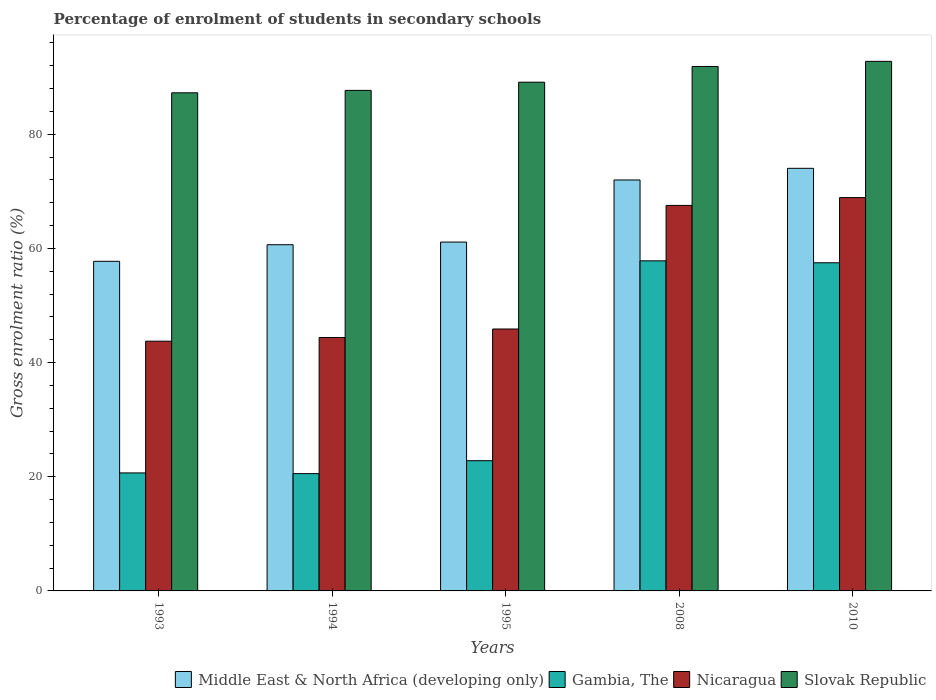How many bars are there on the 4th tick from the left?
Give a very brief answer. 4. What is the label of the 4th group of bars from the left?
Offer a terse response. 2008. In how many cases, is the number of bars for a given year not equal to the number of legend labels?
Your answer should be very brief. 0. What is the percentage of students enrolled in secondary schools in Slovak Republic in 2010?
Your answer should be compact. 92.78. Across all years, what is the maximum percentage of students enrolled in secondary schools in Nicaragua?
Your response must be concise. 68.91. Across all years, what is the minimum percentage of students enrolled in secondary schools in Gambia, The?
Ensure brevity in your answer.  20.55. In which year was the percentage of students enrolled in secondary schools in Nicaragua maximum?
Offer a very short reply. 2010. In which year was the percentage of students enrolled in secondary schools in Middle East & North Africa (developing only) minimum?
Make the answer very short. 1993. What is the total percentage of students enrolled in secondary schools in Nicaragua in the graph?
Your response must be concise. 270.48. What is the difference between the percentage of students enrolled in secondary schools in Gambia, The in 2008 and that in 2010?
Ensure brevity in your answer.  0.34. What is the difference between the percentage of students enrolled in secondary schools in Gambia, The in 2010 and the percentage of students enrolled in secondary schools in Nicaragua in 1994?
Keep it short and to the point. 13.09. What is the average percentage of students enrolled in secondary schools in Slovak Republic per year?
Offer a very short reply. 89.75. In the year 1993, what is the difference between the percentage of students enrolled in secondary schools in Gambia, The and percentage of students enrolled in secondary schools in Nicaragua?
Keep it short and to the point. -23.08. In how many years, is the percentage of students enrolled in secondary schools in Slovak Republic greater than 64 %?
Provide a succinct answer. 5. What is the ratio of the percentage of students enrolled in secondary schools in Gambia, The in 1995 to that in 2010?
Your answer should be very brief. 0.4. Is the difference between the percentage of students enrolled in secondary schools in Gambia, The in 1993 and 2010 greater than the difference between the percentage of students enrolled in secondary schools in Nicaragua in 1993 and 2010?
Keep it short and to the point. No. What is the difference between the highest and the second highest percentage of students enrolled in secondary schools in Slovak Republic?
Provide a succinct answer. 0.9. What is the difference between the highest and the lowest percentage of students enrolled in secondary schools in Gambia, The?
Make the answer very short. 37.28. In how many years, is the percentage of students enrolled in secondary schools in Slovak Republic greater than the average percentage of students enrolled in secondary schools in Slovak Republic taken over all years?
Ensure brevity in your answer.  2. What does the 3rd bar from the left in 2010 represents?
Offer a terse response. Nicaragua. What does the 1st bar from the right in 1995 represents?
Provide a short and direct response. Slovak Republic. How many bars are there?
Give a very brief answer. 20. Are all the bars in the graph horizontal?
Give a very brief answer. No. How many years are there in the graph?
Provide a succinct answer. 5. Does the graph contain grids?
Give a very brief answer. No. Where does the legend appear in the graph?
Your answer should be very brief. Bottom right. How many legend labels are there?
Give a very brief answer. 4. How are the legend labels stacked?
Provide a succinct answer. Horizontal. What is the title of the graph?
Give a very brief answer. Percentage of enrolment of students in secondary schools. Does "Vanuatu" appear as one of the legend labels in the graph?
Offer a terse response. No. What is the label or title of the X-axis?
Your answer should be compact. Years. What is the label or title of the Y-axis?
Keep it short and to the point. Gross enrolment ratio (%). What is the Gross enrolment ratio (%) in Middle East & North Africa (developing only) in 1993?
Your answer should be very brief. 57.75. What is the Gross enrolment ratio (%) in Gambia, The in 1993?
Your answer should be very brief. 20.67. What is the Gross enrolment ratio (%) of Nicaragua in 1993?
Your answer should be compact. 43.75. What is the Gross enrolment ratio (%) of Slovak Republic in 1993?
Your answer should be very brief. 87.27. What is the Gross enrolment ratio (%) of Middle East & North Africa (developing only) in 1994?
Keep it short and to the point. 60.65. What is the Gross enrolment ratio (%) of Gambia, The in 1994?
Your answer should be very brief. 20.55. What is the Gross enrolment ratio (%) of Nicaragua in 1994?
Make the answer very short. 44.4. What is the Gross enrolment ratio (%) of Slovak Republic in 1994?
Offer a terse response. 87.69. What is the Gross enrolment ratio (%) of Middle East & North Africa (developing only) in 1995?
Your answer should be compact. 61.11. What is the Gross enrolment ratio (%) of Gambia, The in 1995?
Your answer should be very brief. 22.81. What is the Gross enrolment ratio (%) of Nicaragua in 1995?
Keep it short and to the point. 45.89. What is the Gross enrolment ratio (%) of Slovak Republic in 1995?
Your response must be concise. 89.13. What is the Gross enrolment ratio (%) in Middle East & North Africa (developing only) in 2008?
Your answer should be compact. 71.99. What is the Gross enrolment ratio (%) in Gambia, The in 2008?
Your answer should be compact. 57.83. What is the Gross enrolment ratio (%) of Nicaragua in 2008?
Your response must be concise. 67.54. What is the Gross enrolment ratio (%) in Slovak Republic in 2008?
Your response must be concise. 91.88. What is the Gross enrolment ratio (%) in Middle East & North Africa (developing only) in 2010?
Provide a succinct answer. 74.04. What is the Gross enrolment ratio (%) in Gambia, The in 2010?
Offer a very short reply. 57.49. What is the Gross enrolment ratio (%) in Nicaragua in 2010?
Make the answer very short. 68.91. What is the Gross enrolment ratio (%) in Slovak Republic in 2010?
Provide a succinct answer. 92.78. Across all years, what is the maximum Gross enrolment ratio (%) of Middle East & North Africa (developing only)?
Provide a succinct answer. 74.04. Across all years, what is the maximum Gross enrolment ratio (%) of Gambia, The?
Your response must be concise. 57.83. Across all years, what is the maximum Gross enrolment ratio (%) of Nicaragua?
Provide a succinct answer. 68.91. Across all years, what is the maximum Gross enrolment ratio (%) in Slovak Republic?
Your answer should be very brief. 92.78. Across all years, what is the minimum Gross enrolment ratio (%) of Middle East & North Africa (developing only)?
Offer a very short reply. 57.75. Across all years, what is the minimum Gross enrolment ratio (%) in Gambia, The?
Ensure brevity in your answer.  20.55. Across all years, what is the minimum Gross enrolment ratio (%) in Nicaragua?
Offer a terse response. 43.75. Across all years, what is the minimum Gross enrolment ratio (%) of Slovak Republic?
Provide a short and direct response. 87.27. What is the total Gross enrolment ratio (%) in Middle East & North Africa (developing only) in the graph?
Keep it short and to the point. 325.54. What is the total Gross enrolment ratio (%) of Gambia, The in the graph?
Offer a terse response. 179.35. What is the total Gross enrolment ratio (%) in Nicaragua in the graph?
Provide a succinct answer. 270.48. What is the total Gross enrolment ratio (%) of Slovak Republic in the graph?
Offer a terse response. 448.73. What is the difference between the Gross enrolment ratio (%) in Middle East & North Africa (developing only) in 1993 and that in 1994?
Offer a very short reply. -2.91. What is the difference between the Gross enrolment ratio (%) of Gambia, The in 1993 and that in 1994?
Keep it short and to the point. 0.12. What is the difference between the Gross enrolment ratio (%) of Nicaragua in 1993 and that in 1994?
Your answer should be very brief. -0.65. What is the difference between the Gross enrolment ratio (%) of Slovak Republic in 1993 and that in 1994?
Offer a terse response. -0.42. What is the difference between the Gross enrolment ratio (%) of Middle East & North Africa (developing only) in 1993 and that in 1995?
Offer a terse response. -3.37. What is the difference between the Gross enrolment ratio (%) of Gambia, The in 1993 and that in 1995?
Your answer should be very brief. -2.14. What is the difference between the Gross enrolment ratio (%) in Nicaragua in 1993 and that in 1995?
Your answer should be very brief. -2.13. What is the difference between the Gross enrolment ratio (%) of Slovak Republic in 1993 and that in 1995?
Keep it short and to the point. -1.86. What is the difference between the Gross enrolment ratio (%) in Middle East & North Africa (developing only) in 1993 and that in 2008?
Make the answer very short. -14.25. What is the difference between the Gross enrolment ratio (%) in Gambia, The in 1993 and that in 2008?
Your answer should be compact. -37.15. What is the difference between the Gross enrolment ratio (%) in Nicaragua in 1993 and that in 2008?
Your answer should be very brief. -23.79. What is the difference between the Gross enrolment ratio (%) in Slovak Republic in 1993 and that in 2008?
Make the answer very short. -4.61. What is the difference between the Gross enrolment ratio (%) in Middle East & North Africa (developing only) in 1993 and that in 2010?
Make the answer very short. -16.29. What is the difference between the Gross enrolment ratio (%) in Gambia, The in 1993 and that in 2010?
Offer a terse response. -36.81. What is the difference between the Gross enrolment ratio (%) of Nicaragua in 1993 and that in 2010?
Provide a succinct answer. -25.16. What is the difference between the Gross enrolment ratio (%) of Slovak Republic in 1993 and that in 2010?
Provide a succinct answer. -5.51. What is the difference between the Gross enrolment ratio (%) in Middle East & North Africa (developing only) in 1994 and that in 1995?
Provide a succinct answer. -0.46. What is the difference between the Gross enrolment ratio (%) of Gambia, The in 1994 and that in 1995?
Make the answer very short. -2.27. What is the difference between the Gross enrolment ratio (%) of Nicaragua in 1994 and that in 1995?
Make the answer very short. -1.49. What is the difference between the Gross enrolment ratio (%) in Slovak Republic in 1994 and that in 1995?
Offer a terse response. -1.44. What is the difference between the Gross enrolment ratio (%) of Middle East & North Africa (developing only) in 1994 and that in 2008?
Provide a short and direct response. -11.34. What is the difference between the Gross enrolment ratio (%) in Gambia, The in 1994 and that in 2008?
Make the answer very short. -37.28. What is the difference between the Gross enrolment ratio (%) in Nicaragua in 1994 and that in 2008?
Make the answer very short. -23.14. What is the difference between the Gross enrolment ratio (%) in Slovak Republic in 1994 and that in 2008?
Provide a short and direct response. -4.19. What is the difference between the Gross enrolment ratio (%) in Middle East & North Africa (developing only) in 1994 and that in 2010?
Your response must be concise. -13.39. What is the difference between the Gross enrolment ratio (%) of Gambia, The in 1994 and that in 2010?
Provide a short and direct response. -36.94. What is the difference between the Gross enrolment ratio (%) of Nicaragua in 1994 and that in 2010?
Keep it short and to the point. -24.51. What is the difference between the Gross enrolment ratio (%) of Slovak Republic in 1994 and that in 2010?
Give a very brief answer. -5.09. What is the difference between the Gross enrolment ratio (%) of Middle East & North Africa (developing only) in 1995 and that in 2008?
Give a very brief answer. -10.88. What is the difference between the Gross enrolment ratio (%) in Gambia, The in 1995 and that in 2008?
Your response must be concise. -35.01. What is the difference between the Gross enrolment ratio (%) of Nicaragua in 1995 and that in 2008?
Provide a succinct answer. -21.65. What is the difference between the Gross enrolment ratio (%) in Slovak Republic in 1995 and that in 2008?
Offer a very short reply. -2.75. What is the difference between the Gross enrolment ratio (%) in Middle East & North Africa (developing only) in 1995 and that in 2010?
Provide a short and direct response. -12.92. What is the difference between the Gross enrolment ratio (%) in Gambia, The in 1995 and that in 2010?
Give a very brief answer. -34.67. What is the difference between the Gross enrolment ratio (%) in Nicaragua in 1995 and that in 2010?
Provide a succinct answer. -23.02. What is the difference between the Gross enrolment ratio (%) of Slovak Republic in 1995 and that in 2010?
Your answer should be very brief. -3.65. What is the difference between the Gross enrolment ratio (%) of Middle East & North Africa (developing only) in 2008 and that in 2010?
Ensure brevity in your answer.  -2.04. What is the difference between the Gross enrolment ratio (%) of Gambia, The in 2008 and that in 2010?
Keep it short and to the point. 0.34. What is the difference between the Gross enrolment ratio (%) in Nicaragua in 2008 and that in 2010?
Your response must be concise. -1.37. What is the difference between the Gross enrolment ratio (%) of Slovak Republic in 2008 and that in 2010?
Keep it short and to the point. -0.9. What is the difference between the Gross enrolment ratio (%) in Middle East & North Africa (developing only) in 1993 and the Gross enrolment ratio (%) in Gambia, The in 1994?
Your answer should be very brief. 37.2. What is the difference between the Gross enrolment ratio (%) in Middle East & North Africa (developing only) in 1993 and the Gross enrolment ratio (%) in Nicaragua in 1994?
Offer a terse response. 13.35. What is the difference between the Gross enrolment ratio (%) in Middle East & North Africa (developing only) in 1993 and the Gross enrolment ratio (%) in Slovak Republic in 1994?
Give a very brief answer. -29.94. What is the difference between the Gross enrolment ratio (%) of Gambia, The in 1993 and the Gross enrolment ratio (%) of Nicaragua in 1994?
Ensure brevity in your answer.  -23.72. What is the difference between the Gross enrolment ratio (%) in Gambia, The in 1993 and the Gross enrolment ratio (%) in Slovak Republic in 1994?
Your answer should be very brief. -67.02. What is the difference between the Gross enrolment ratio (%) of Nicaragua in 1993 and the Gross enrolment ratio (%) of Slovak Republic in 1994?
Provide a short and direct response. -43.94. What is the difference between the Gross enrolment ratio (%) in Middle East & North Africa (developing only) in 1993 and the Gross enrolment ratio (%) in Gambia, The in 1995?
Provide a succinct answer. 34.93. What is the difference between the Gross enrolment ratio (%) of Middle East & North Africa (developing only) in 1993 and the Gross enrolment ratio (%) of Nicaragua in 1995?
Provide a succinct answer. 11.86. What is the difference between the Gross enrolment ratio (%) in Middle East & North Africa (developing only) in 1993 and the Gross enrolment ratio (%) in Slovak Republic in 1995?
Give a very brief answer. -31.38. What is the difference between the Gross enrolment ratio (%) of Gambia, The in 1993 and the Gross enrolment ratio (%) of Nicaragua in 1995?
Offer a very short reply. -25.21. What is the difference between the Gross enrolment ratio (%) of Gambia, The in 1993 and the Gross enrolment ratio (%) of Slovak Republic in 1995?
Ensure brevity in your answer.  -68.45. What is the difference between the Gross enrolment ratio (%) of Nicaragua in 1993 and the Gross enrolment ratio (%) of Slovak Republic in 1995?
Offer a terse response. -45.37. What is the difference between the Gross enrolment ratio (%) in Middle East & North Africa (developing only) in 1993 and the Gross enrolment ratio (%) in Gambia, The in 2008?
Ensure brevity in your answer.  -0.08. What is the difference between the Gross enrolment ratio (%) of Middle East & North Africa (developing only) in 1993 and the Gross enrolment ratio (%) of Nicaragua in 2008?
Offer a very short reply. -9.79. What is the difference between the Gross enrolment ratio (%) of Middle East & North Africa (developing only) in 1993 and the Gross enrolment ratio (%) of Slovak Republic in 2008?
Make the answer very short. -34.13. What is the difference between the Gross enrolment ratio (%) in Gambia, The in 1993 and the Gross enrolment ratio (%) in Nicaragua in 2008?
Offer a terse response. -46.86. What is the difference between the Gross enrolment ratio (%) in Gambia, The in 1993 and the Gross enrolment ratio (%) in Slovak Republic in 2008?
Make the answer very short. -71.2. What is the difference between the Gross enrolment ratio (%) of Nicaragua in 1993 and the Gross enrolment ratio (%) of Slovak Republic in 2008?
Your response must be concise. -48.13. What is the difference between the Gross enrolment ratio (%) of Middle East & North Africa (developing only) in 1993 and the Gross enrolment ratio (%) of Gambia, The in 2010?
Provide a short and direct response. 0.26. What is the difference between the Gross enrolment ratio (%) in Middle East & North Africa (developing only) in 1993 and the Gross enrolment ratio (%) in Nicaragua in 2010?
Your answer should be very brief. -11.16. What is the difference between the Gross enrolment ratio (%) of Middle East & North Africa (developing only) in 1993 and the Gross enrolment ratio (%) of Slovak Republic in 2010?
Give a very brief answer. -35.03. What is the difference between the Gross enrolment ratio (%) of Gambia, The in 1993 and the Gross enrolment ratio (%) of Nicaragua in 2010?
Keep it short and to the point. -48.23. What is the difference between the Gross enrolment ratio (%) in Gambia, The in 1993 and the Gross enrolment ratio (%) in Slovak Republic in 2010?
Provide a succinct answer. -72.1. What is the difference between the Gross enrolment ratio (%) in Nicaragua in 1993 and the Gross enrolment ratio (%) in Slovak Republic in 2010?
Your response must be concise. -49.02. What is the difference between the Gross enrolment ratio (%) in Middle East & North Africa (developing only) in 1994 and the Gross enrolment ratio (%) in Gambia, The in 1995?
Your answer should be very brief. 37.84. What is the difference between the Gross enrolment ratio (%) in Middle East & North Africa (developing only) in 1994 and the Gross enrolment ratio (%) in Nicaragua in 1995?
Ensure brevity in your answer.  14.77. What is the difference between the Gross enrolment ratio (%) of Middle East & North Africa (developing only) in 1994 and the Gross enrolment ratio (%) of Slovak Republic in 1995?
Ensure brevity in your answer.  -28.47. What is the difference between the Gross enrolment ratio (%) in Gambia, The in 1994 and the Gross enrolment ratio (%) in Nicaragua in 1995?
Give a very brief answer. -25.34. What is the difference between the Gross enrolment ratio (%) of Gambia, The in 1994 and the Gross enrolment ratio (%) of Slovak Republic in 1995?
Give a very brief answer. -68.58. What is the difference between the Gross enrolment ratio (%) in Nicaragua in 1994 and the Gross enrolment ratio (%) in Slovak Republic in 1995?
Provide a succinct answer. -44.73. What is the difference between the Gross enrolment ratio (%) in Middle East & North Africa (developing only) in 1994 and the Gross enrolment ratio (%) in Gambia, The in 2008?
Keep it short and to the point. 2.82. What is the difference between the Gross enrolment ratio (%) in Middle East & North Africa (developing only) in 1994 and the Gross enrolment ratio (%) in Nicaragua in 2008?
Your answer should be compact. -6.89. What is the difference between the Gross enrolment ratio (%) of Middle East & North Africa (developing only) in 1994 and the Gross enrolment ratio (%) of Slovak Republic in 2008?
Offer a very short reply. -31.23. What is the difference between the Gross enrolment ratio (%) of Gambia, The in 1994 and the Gross enrolment ratio (%) of Nicaragua in 2008?
Provide a short and direct response. -46.99. What is the difference between the Gross enrolment ratio (%) of Gambia, The in 1994 and the Gross enrolment ratio (%) of Slovak Republic in 2008?
Your answer should be very brief. -71.33. What is the difference between the Gross enrolment ratio (%) in Nicaragua in 1994 and the Gross enrolment ratio (%) in Slovak Republic in 2008?
Offer a terse response. -47.48. What is the difference between the Gross enrolment ratio (%) of Middle East & North Africa (developing only) in 1994 and the Gross enrolment ratio (%) of Gambia, The in 2010?
Give a very brief answer. 3.16. What is the difference between the Gross enrolment ratio (%) in Middle East & North Africa (developing only) in 1994 and the Gross enrolment ratio (%) in Nicaragua in 2010?
Keep it short and to the point. -8.26. What is the difference between the Gross enrolment ratio (%) in Middle East & North Africa (developing only) in 1994 and the Gross enrolment ratio (%) in Slovak Republic in 2010?
Ensure brevity in your answer.  -32.12. What is the difference between the Gross enrolment ratio (%) of Gambia, The in 1994 and the Gross enrolment ratio (%) of Nicaragua in 2010?
Offer a terse response. -48.36. What is the difference between the Gross enrolment ratio (%) in Gambia, The in 1994 and the Gross enrolment ratio (%) in Slovak Republic in 2010?
Your answer should be very brief. -72.23. What is the difference between the Gross enrolment ratio (%) of Nicaragua in 1994 and the Gross enrolment ratio (%) of Slovak Republic in 2010?
Your response must be concise. -48.38. What is the difference between the Gross enrolment ratio (%) in Middle East & North Africa (developing only) in 1995 and the Gross enrolment ratio (%) in Gambia, The in 2008?
Your answer should be compact. 3.29. What is the difference between the Gross enrolment ratio (%) in Middle East & North Africa (developing only) in 1995 and the Gross enrolment ratio (%) in Nicaragua in 2008?
Make the answer very short. -6.42. What is the difference between the Gross enrolment ratio (%) of Middle East & North Africa (developing only) in 1995 and the Gross enrolment ratio (%) of Slovak Republic in 2008?
Make the answer very short. -30.76. What is the difference between the Gross enrolment ratio (%) in Gambia, The in 1995 and the Gross enrolment ratio (%) in Nicaragua in 2008?
Make the answer very short. -44.72. What is the difference between the Gross enrolment ratio (%) of Gambia, The in 1995 and the Gross enrolment ratio (%) of Slovak Republic in 2008?
Provide a succinct answer. -69.06. What is the difference between the Gross enrolment ratio (%) in Nicaragua in 1995 and the Gross enrolment ratio (%) in Slovak Republic in 2008?
Your response must be concise. -45.99. What is the difference between the Gross enrolment ratio (%) of Middle East & North Africa (developing only) in 1995 and the Gross enrolment ratio (%) of Gambia, The in 2010?
Offer a very short reply. 3.63. What is the difference between the Gross enrolment ratio (%) in Middle East & North Africa (developing only) in 1995 and the Gross enrolment ratio (%) in Nicaragua in 2010?
Ensure brevity in your answer.  -7.79. What is the difference between the Gross enrolment ratio (%) in Middle East & North Africa (developing only) in 1995 and the Gross enrolment ratio (%) in Slovak Republic in 2010?
Your answer should be very brief. -31.66. What is the difference between the Gross enrolment ratio (%) of Gambia, The in 1995 and the Gross enrolment ratio (%) of Nicaragua in 2010?
Your answer should be very brief. -46.09. What is the difference between the Gross enrolment ratio (%) in Gambia, The in 1995 and the Gross enrolment ratio (%) in Slovak Republic in 2010?
Keep it short and to the point. -69.96. What is the difference between the Gross enrolment ratio (%) of Nicaragua in 1995 and the Gross enrolment ratio (%) of Slovak Republic in 2010?
Ensure brevity in your answer.  -46.89. What is the difference between the Gross enrolment ratio (%) of Middle East & North Africa (developing only) in 2008 and the Gross enrolment ratio (%) of Gambia, The in 2010?
Your answer should be very brief. 14.51. What is the difference between the Gross enrolment ratio (%) in Middle East & North Africa (developing only) in 2008 and the Gross enrolment ratio (%) in Nicaragua in 2010?
Give a very brief answer. 3.08. What is the difference between the Gross enrolment ratio (%) in Middle East & North Africa (developing only) in 2008 and the Gross enrolment ratio (%) in Slovak Republic in 2010?
Offer a terse response. -20.78. What is the difference between the Gross enrolment ratio (%) of Gambia, The in 2008 and the Gross enrolment ratio (%) of Nicaragua in 2010?
Your response must be concise. -11.08. What is the difference between the Gross enrolment ratio (%) of Gambia, The in 2008 and the Gross enrolment ratio (%) of Slovak Republic in 2010?
Offer a very short reply. -34.95. What is the difference between the Gross enrolment ratio (%) in Nicaragua in 2008 and the Gross enrolment ratio (%) in Slovak Republic in 2010?
Provide a succinct answer. -25.24. What is the average Gross enrolment ratio (%) of Middle East & North Africa (developing only) per year?
Offer a very short reply. 65.11. What is the average Gross enrolment ratio (%) in Gambia, The per year?
Your answer should be compact. 35.87. What is the average Gross enrolment ratio (%) of Nicaragua per year?
Make the answer very short. 54.1. What is the average Gross enrolment ratio (%) of Slovak Republic per year?
Ensure brevity in your answer.  89.75. In the year 1993, what is the difference between the Gross enrolment ratio (%) in Middle East & North Africa (developing only) and Gross enrolment ratio (%) in Gambia, The?
Offer a terse response. 37.07. In the year 1993, what is the difference between the Gross enrolment ratio (%) of Middle East & North Africa (developing only) and Gross enrolment ratio (%) of Nicaragua?
Keep it short and to the point. 13.99. In the year 1993, what is the difference between the Gross enrolment ratio (%) in Middle East & North Africa (developing only) and Gross enrolment ratio (%) in Slovak Republic?
Keep it short and to the point. -29.52. In the year 1993, what is the difference between the Gross enrolment ratio (%) of Gambia, The and Gross enrolment ratio (%) of Nicaragua?
Provide a short and direct response. -23.08. In the year 1993, what is the difference between the Gross enrolment ratio (%) in Gambia, The and Gross enrolment ratio (%) in Slovak Republic?
Offer a terse response. -66.59. In the year 1993, what is the difference between the Gross enrolment ratio (%) in Nicaragua and Gross enrolment ratio (%) in Slovak Republic?
Offer a very short reply. -43.52. In the year 1994, what is the difference between the Gross enrolment ratio (%) in Middle East & North Africa (developing only) and Gross enrolment ratio (%) in Gambia, The?
Your answer should be compact. 40.1. In the year 1994, what is the difference between the Gross enrolment ratio (%) of Middle East & North Africa (developing only) and Gross enrolment ratio (%) of Nicaragua?
Give a very brief answer. 16.25. In the year 1994, what is the difference between the Gross enrolment ratio (%) of Middle East & North Africa (developing only) and Gross enrolment ratio (%) of Slovak Republic?
Your answer should be very brief. -27.04. In the year 1994, what is the difference between the Gross enrolment ratio (%) in Gambia, The and Gross enrolment ratio (%) in Nicaragua?
Offer a very short reply. -23.85. In the year 1994, what is the difference between the Gross enrolment ratio (%) of Gambia, The and Gross enrolment ratio (%) of Slovak Republic?
Offer a very short reply. -67.14. In the year 1994, what is the difference between the Gross enrolment ratio (%) of Nicaragua and Gross enrolment ratio (%) of Slovak Republic?
Make the answer very short. -43.29. In the year 1995, what is the difference between the Gross enrolment ratio (%) in Middle East & North Africa (developing only) and Gross enrolment ratio (%) in Gambia, The?
Make the answer very short. 38.3. In the year 1995, what is the difference between the Gross enrolment ratio (%) of Middle East & North Africa (developing only) and Gross enrolment ratio (%) of Nicaragua?
Provide a short and direct response. 15.23. In the year 1995, what is the difference between the Gross enrolment ratio (%) of Middle East & North Africa (developing only) and Gross enrolment ratio (%) of Slovak Republic?
Your answer should be compact. -28.01. In the year 1995, what is the difference between the Gross enrolment ratio (%) in Gambia, The and Gross enrolment ratio (%) in Nicaragua?
Make the answer very short. -23.07. In the year 1995, what is the difference between the Gross enrolment ratio (%) of Gambia, The and Gross enrolment ratio (%) of Slovak Republic?
Keep it short and to the point. -66.31. In the year 1995, what is the difference between the Gross enrolment ratio (%) in Nicaragua and Gross enrolment ratio (%) in Slovak Republic?
Give a very brief answer. -43.24. In the year 2008, what is the difference between the Gross enrolment ratio (%) in Middle East & North Africa (developing only) and Gross enrolment ratio (%) in Gambia, The?
Provide a succinct answer. 14.17. In the year 2008, what is the difference between the Gross enrolment ratio (%) in Middle East & North Africa (developing only) and Gross enrolment ratio (%) in Nicaragua?
Ensure brevity in your answer.  4.46. In the year 2008, what is the difference between the Gross enrolment ratio (%) of Middle East & North Africa (developing only) and Gross enrolment ratio (%) of Slovak Republic?
Ensure brevity in your answer.  -19.88. In the year 2008, what is the difference between the Gross enrolment ratio (%) in Gambia, The and Gross enrolment ratio (%) in Nicaragua?
Provide a succinct answer. -9.71. In the year 2008, what is the difference between the Gross enrolment ratio (%) in Gambia, The and Gross enrolment ratio (%) in Slovak Republic?
Give a very brief answer. -34.05. In the year 2008, what is the difference between the Gross enrolment ratio (%) in Nicaragua and Gross enrolment ratio (%) in Slovak Republic?
Your answer should be compact. -24.34. In the year 2010, what is the difference between the Gross enrolment ratio (%) of Middle East & North Africa (developing only) and Gross enrolment ratio (%) of Gambia, The?
Your response must be concise. 16.55. In the year 2010, what is the difference between the Gross enrolment ratio (%) of Middle East & North Africa (developing only) and Gross enrolment ratio (%) of Nicaragua?
Offer a terse response. 5.13. In the year 2010, what is the difference between the Gross enrolment ratio (%) in Middle East & North Africa (developing only) and Gross enrolment ratio (%) in Slovak Republic?
Your answer should be very brief. -18.74. In the year 2010, what is the difference between the Gross enrolment ratio (%) in Gambia, The and Gross enrolment ratio (%) in Nicaragua?
Provide a short and direct response. -11.42. In the year 2010, what is the difference between the Gross enrolment ratio (%) in Gambia, The and Gross enrolment ratio (%) in Slovak Republic?
Give a very brief answer. -35.29. In the year 2010, what is the difference between the Gross enrolment ratio (%) of Nicaragua and Gross enrolment ratio (%) of Slovak Republic?
Offer a terse response. -23.87. What is the ratio of the Gross enrolment ratio (%) in Middle East & North Africa (developing only) in 1993 to that in 1994?
Offer a very short reply. 0.95. What is the ratio of the Gross enrolment ratio (%) of Nicaragua in 1993 to that in 1994?
Offer a very short reply. 0.99. What is the ratio of the Gross enrolment ratio (%) of Slovak Republic in 1993 to that in 1994?
Provide a succinct answer. 1. What is the ratio of the Gross enrolment ratio (%) in Middle East & North Africa (developing only) in 1993 to that in 1995?
Provide a succinct answer. 0.94. What is the ratio of the Gross enrolment ratio (%) of Gambia, The in 1993 to that in 1995?
Make the answer very short. 0.91. What is the ratio of the Gross enrolment ratio (%) of Nicaragua in 1993 to that in 1995?
Your response must be concise. 0.95. What is the ratio of the Gross enrolment ratio (%) in Slovak Republic in 1993 to that in 1995?
Make the answer very short. 0.98. What is the ratio of the Gross enrolment ratio (%) in Middle East & North Africa (developing only) in 1993 to that in 2008?
Your answer should be very brief. 0.8. What is the ratio of the Gross enrolment ratio (%) in Gambia, The in 1993 to that in 2008?
Your response must be concise. 0.36. What is the ratio of the Gross enrolment ratio (%) in Nicaragua in 1993 to that in 2008?
Provide a short and direct response. 0.65. What is the ratio of the Gross enrolment ratio (%) in Slovak Republic in 1993 to that in 2008?
Offer a very short reply. 0.95. What is the ratio of the Gross enrolment ratio (%) of Middle East & North Africa (developing only) in 1993 to that in 2010?
Provide a short and direct response. 0.78. What is the ratio of the Gross enrolment ratio (%) of Gambia, The in 1993 to that in 2010?
Provide a short and direct response. 0.36. What is the ratio of the Gross enrolment ratio (%) in Nicaragua in 1993 to that in 2010?
Keep it short and to the point. 0.63. What is the ratio of the Gross enrolment ratio (%) of Slovak Republic in 1993 to that in 2010?
Keep it short and to the point. 0.94. What is the ratio of the Gross enrolment ratio (%) of Middle East & North Africa (developing only) in 1994 to that in 1995?
Offer a very short reply. 0.99. What is the ratio of the Gross enrolment ratio (%) of Gambia, The in 1994 to that in 1995?
Make the answer very short. 0.9. What is the ratio of the Gross enrolment ratio (%) in Nicaragua in 1994 to that in 1995?
Ensure brevity in your answer.  0.97. What is the ratio of the Gross enrolment ratio (%) of Slovak Republic in 1994 to that in 1995?
Make the answer very short. 0.98. What is the ratio of the Gross enrolment ratio (%) in Middle East & North Africa (developing only) in 1994 to that in 2008?
Your answer should be compact. 0.84. What is the ratio of the Gross enrolment ratio (%) in Gambia, The in 1994 to that in 2008?
Offer a very short reply. 0.36. What is the ratio of the Gross enrolment ratio (%) in Nicaragua in 1994 to that in 2008?
Your answer should be compact. 0.66. What is the ratio of the Gross enrolment ratio (%) of Slovak Republic in 1994 to that in 2008?
Provide a succinct answer. 0.95. What is the ratio of the Gross enrolment ratio (%) of Middle East & North Africa (developing only) in 1994 to that in 2010?
Your response must be concise. 0.82. What is the ratio of the Gross enrolment ratio (%) of Gambia, The in 1994 to that in 2010?
Keep it short and to the point. 0.36. What is the ratio of the Gross enrolment ratio (%) of Nicaragua in 1994 to that in 2010?
Make the answer very short. 0.64. What is the ratio of the Gross enrolment ratio (%) of Slovak Republic in 1994 to that in 2010?
Provide a short and direct response. 0.95. What is the ratio of the Gross enrolment ratio (%) in Middle East & North Africa (developing only) in 1995 to that in 2008?
Make the answer very short. 0.85. What is the ratio of the Gross enrolment ratio (%) of Gambia, The in 1995 to that in 2008?
Your answer should be compact. 0.39. What is the ratio of the Gross enrolment ratio (%) in Nicaragua in 1995 to that in 2008?
Provide a succinct answer. 0.68. What is the ratio of the Gross enrolment ratio (%) in Slovak Republic in 1995 to that in 2008?
Ensure brevity in your answer.  0.97. What is the ratio of the Gross enrolment ratio (%) of Middle East & North Africa (developing only) in 1995 to that in 2010?
Provide a short and direct response. 0.83. What is the ratio of the Gross enrolment ratio (%) of Gambia, The in 1995 to that in 2010?
Provide a succinct answer. 0.4. What is the ratio of the Gross enrolment ratio (%) of Nicaragua in 1995 to that in 2010?
Give a very brief answer. 0.67. What is the ratio of the Gross enrolment ratio (%) in Slovak Republic in 1995 to that in 2010?
Your answer should be very brief. 0.96. What is the ratio of the Gross enrolment ratio (%) in Middle East & North Africa (developing only) in 2008 to that in 2010?
Keep it short and to the point. 0.97. What is the ratio of the Gross enrolment ratio (%) of Gambia, The in 2008 to that in 2010?
Keep it short and to the point. 1.01. What is the ratio of the Gross enrolment ratio (%) in Nicaragua in 2008 to that in 2010?
Give a very brief answer. 0.98. What is the ratio of the Gross enrolment ratio (%) of Slovak Republic in 2008 to that in 2010?
Your answer should be compact. 0.99. What is the difference between the highest and the second highest Gross enrolment ratio (%) in Middle East & North Africa (developing only)?
Your response must be concise. 2.04. What is the difference between the highest and the second highest Gross enrolment ratio (%) in Gambia, The?
Provide a succinct answer. 0.34. What is the difference between the highest and the second highest Gross enrolment ratio (%) of Nicaragua?
Offer a terse response. 1.37. What is the difference between the highest and the second highest Gross enrolment ratio (%) in Slovak Republic?
Your answer should be compact. 0.9. What is the difference between the highest and the lowest Gross enrolment ratio (%) in Middle East & North Africa (developing only)?
Offer a very short reply. 16.29. What is the difference between the highest and the lowest Gross enrolment ratio (%) of Gambia, The?
Give a very brief answer. 37.28. What is the difference between the highest and the lowest Gross enrolment ratio (%) in Nicaragua?
Your answer should be very brief. 25.16. What is the difference between the highest and the lowest Gross enrolment ratio (%) of Slovak Republic?
Ensure brevity in your answer.  5.51. 